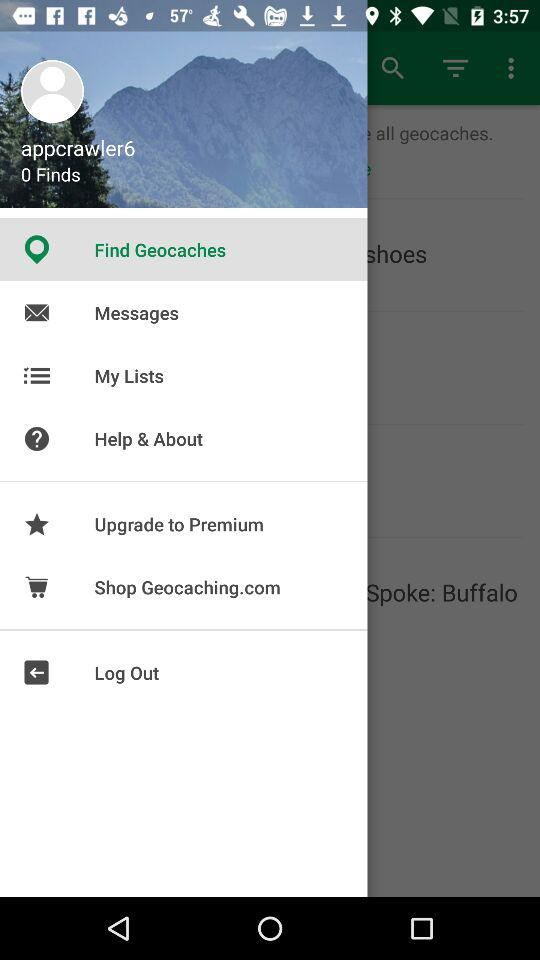How many finds are there? There are 0 finds. 